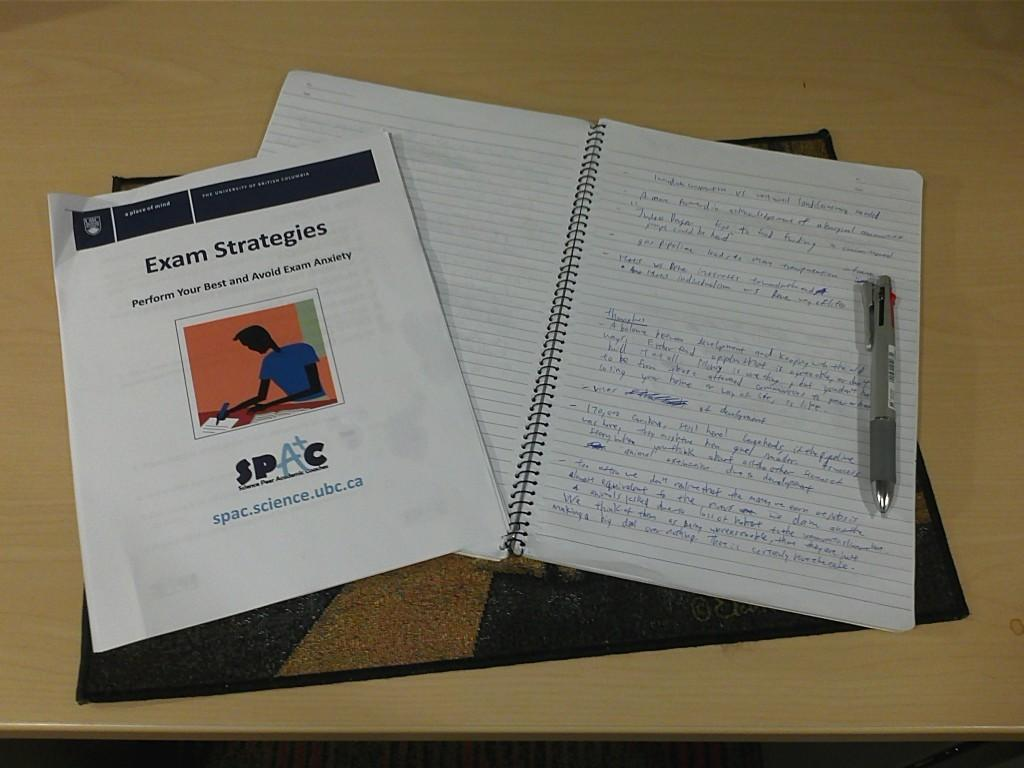Provide a one-sentence caption for the provided image. The exam strategies printout helps one to learn to avoid exam anxiety. 